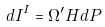<formula> <loc_0><loc_0><loc_500><loc_500>d I ^ { I } = \Omega ^ { \prime } H d P</formula> 